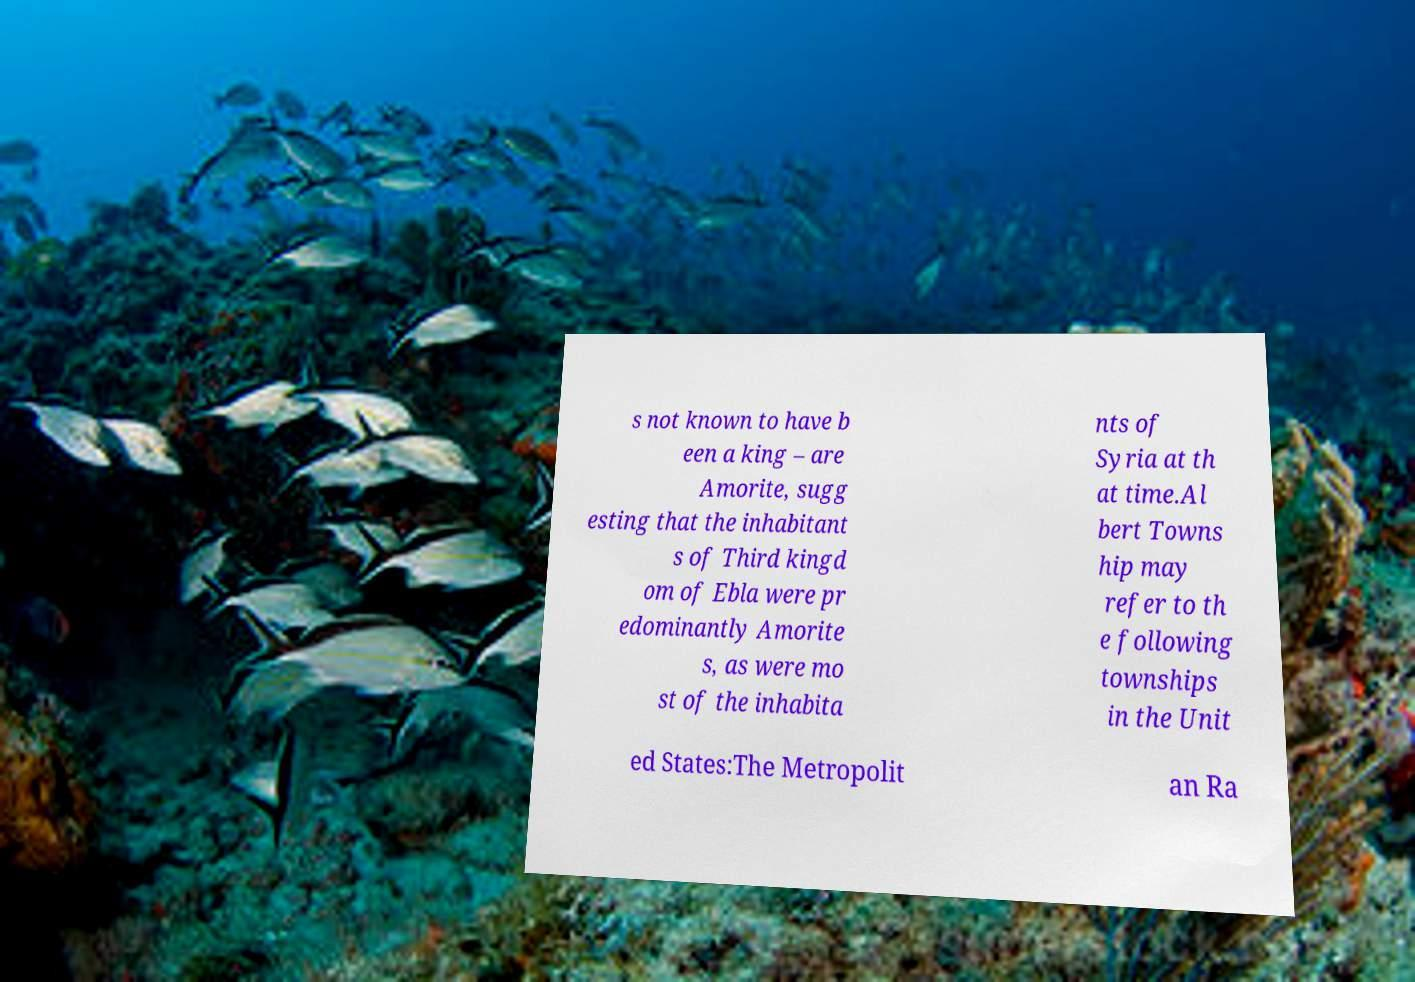Could you extract and type out the text from this image? s not known to have b een a king – are Amorite, sugg esting that the inhabitant s of Third kingd om of Ebla were pr edominantly Amorite s, as were mo st of the inhabita nts of Syria at th at time.Al bert Towns hip may refer to th e following townships in the Unit ed States:The Metropolit an Ra 